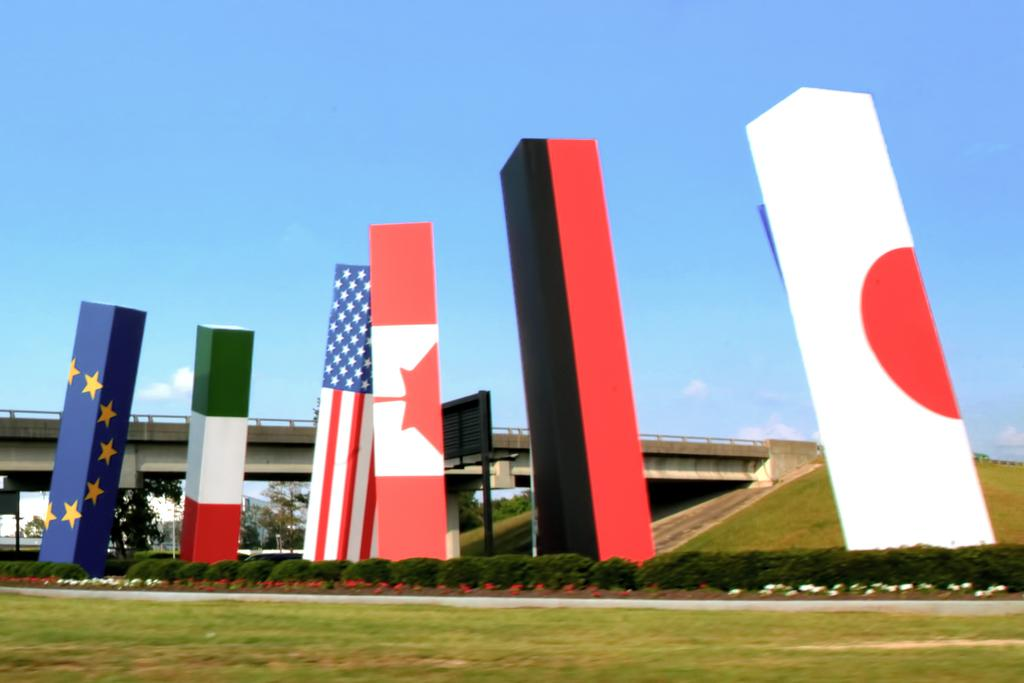What is depicted on the boards in the image? There are flags on the boards in the image. What type of vegetation is present in the image? There are plants with flowers and trees in the image. What type of ground cover is visible in the image? There is grass in the image. What structure can be seen in the image? There is a bridge in the image. What is visible in the background of the image? The sky is visible in the background of the image. What type of organization is responsible for maintaining the sidewalk in the image? There is no sidewalk present in the image, so it is not possible to determine which organization might be responsible for maintaining one. 